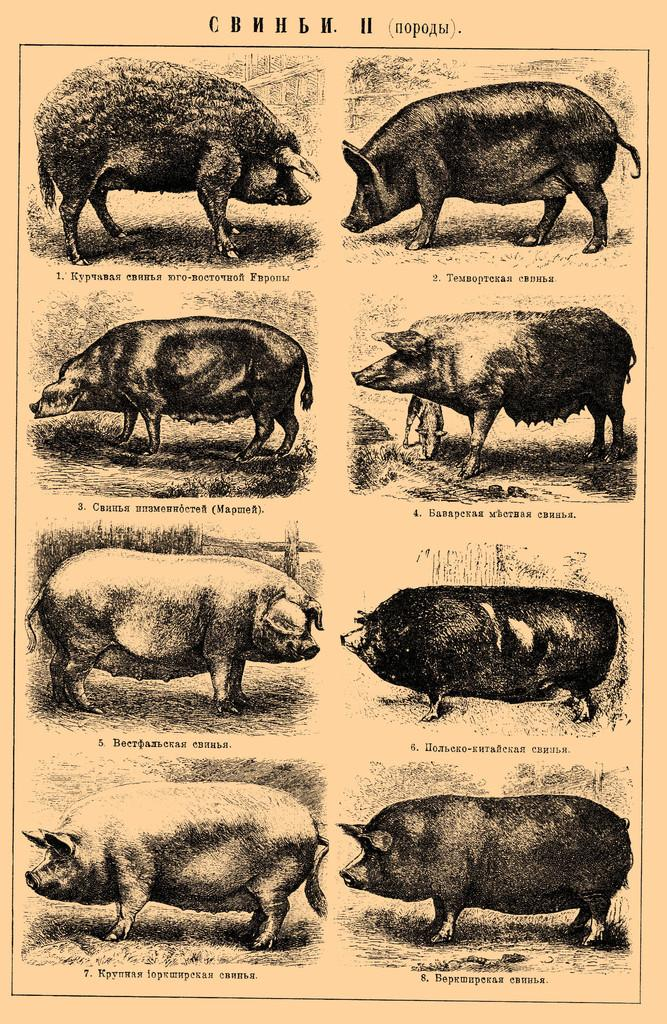What is present in the image related to paper? There is a paper in the image. What is depicted on the paper? The paper contains types of pigs. Are there any words or letters on the paper? Yes, there is text on the paper. What type of snails can be seen on the paper in the image? There are no snails present on the paper in the image; it contains types of pigs. 